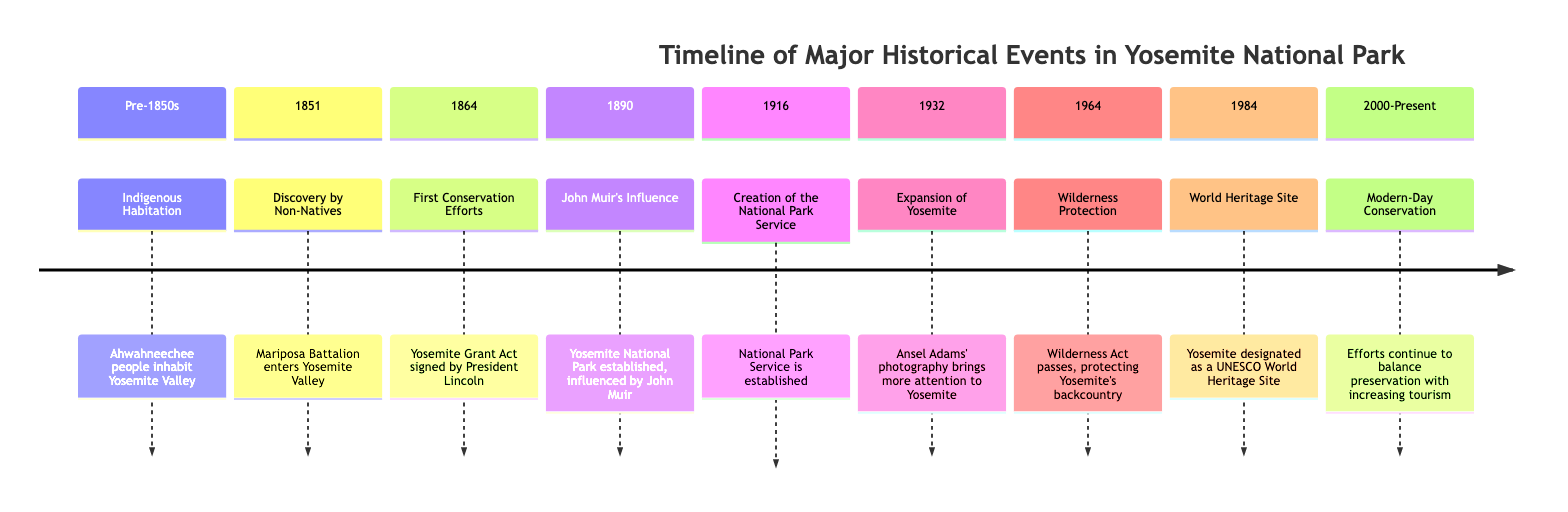What significant event occurred in 1864? The diagram specifies that in 1864, the Yosemite Grant Act was signed by President Lincoln, marking the First Conservation Efforts.
Answer: Yosemite Grant Act Which year marks the establishment of the National Park Service? According to the diagram, the National Park Service was established in 1916, which is indicated as a significant event in the timeline.
Answer: 1916 How many major events are listed in the diagram? The diagram includes a total of eight major events from Indigenous habitation to modern conservation efforts, as indicated by the sections of the timeline.
Answer: Eight What was the primary influence on the establishment of Yosemite National Park? The diagram highlights John Muir's significant influence on the establishment of Yosemite National Park, which occurred in 1890.
Answer: John Muir What does the diagram say about Yosemite in 1984? The timeline states that in 1984, Yosemite was designated as a UNESCO World Heritage Site, which indicates its global importance.
Answer: UNESCO World Heritage Site What event initiated the modern-day conservation efforts in Yosemite? The diagram reveals that the efforts toward balancing preservation with tourism began in the year 2000 and extend to the present, indicating the beginning of modern-day conservation.
Answer: 2000-Present Which event brought more attention to Yosemite through photography? The diagram specifies that in 1932, Ansel Adams' photography brought more attention to Yosemite, highlighting the role of visual media in conservation awareness.
Answer: Ansel Adams' photography In what year did the Wilderness Act pass? The diagram indicates that the Wilderness Act passed in 1964, which is an important milestone for the protection of Yosemite's backcountry.
Answer: 1964 